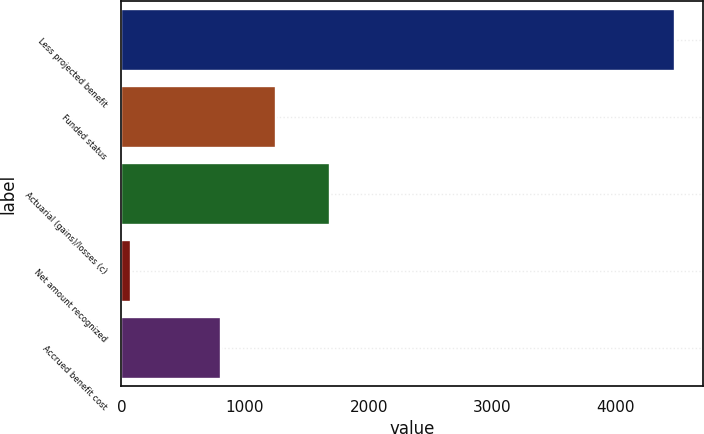Convert chart. <chart><loc_0><loc_0><loc_500><loc_500><bar_chart><fcel>Less projected benefit<fcel>Funded status<fcel>Actuarial (gains)/losses (c)<fcel>Net amount recognized<fcel>Accrued benefit cost<nl><fcel>4481<fcel>1247.7<fcel>1688.4<fcel>74<fcel>807<nl></chart> 